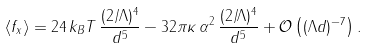Convert formula to latex. <formula><loc_0><loc_0><loc_500><loc_500>\left \langle f _ { x } \right \rangle = 2 4 \, k _ { B } T \, \frac { ( 2 / \Lambda ) ^ { 4 } } { d ^ { 5 } } - 3 2 \pi \kappa \, \alpha ^ { 2 } \, \frac { ( 2 / \Lambda ) ^ { 4 } } { d ^ { 5 } } + \mathcal { O } \left ( ( \Lambda d ) ^ { - 7 } \right ) .</formula> 